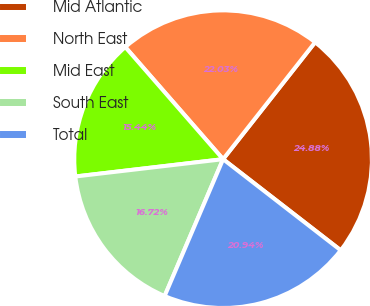Convert chart to OTSL. <chart><loc_0><loc_0><loc_500><loc_500><pie_chart><fcel>Mid Atlantic<fcel>North East<fcel>Mid East<fcel>South East<fcel>Total<nl><fcel>24.88%<fcel>22.03%<fcel>15.44%<fcel>16.72%<fcel>20.94%<nl></chart> 